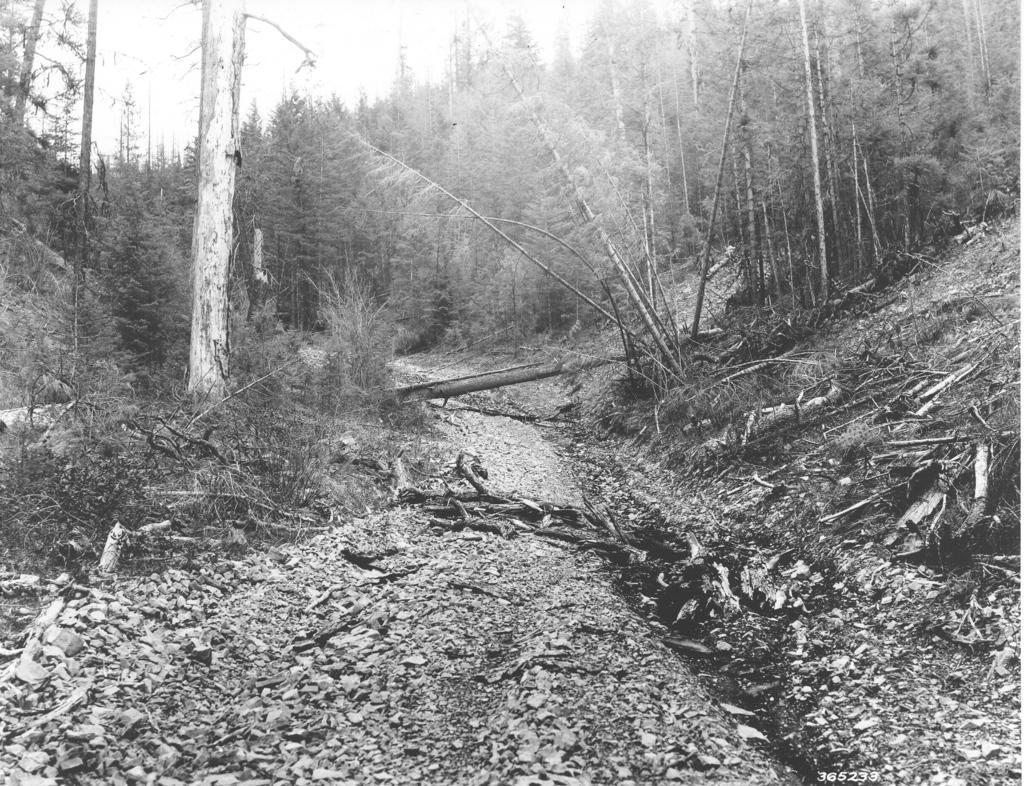Can you describe this image briefly? There is a road on which, there are wooden pieces and a wood which is placed across this road. On both sides of this road, there are plants and trees. In the background, there is sky. 